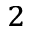Convert formula to latex. <formula><loc_0><loc_0><loc_500><loc_500>_ { 2 }</formula> 